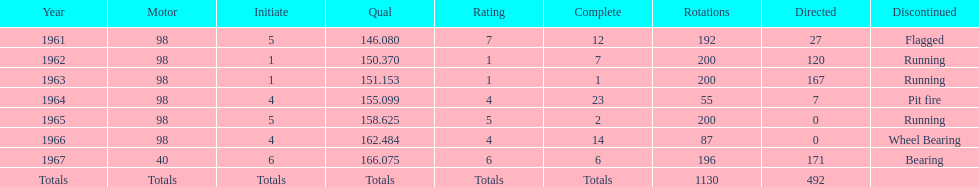What is the most common cause for a retired car? Running. 